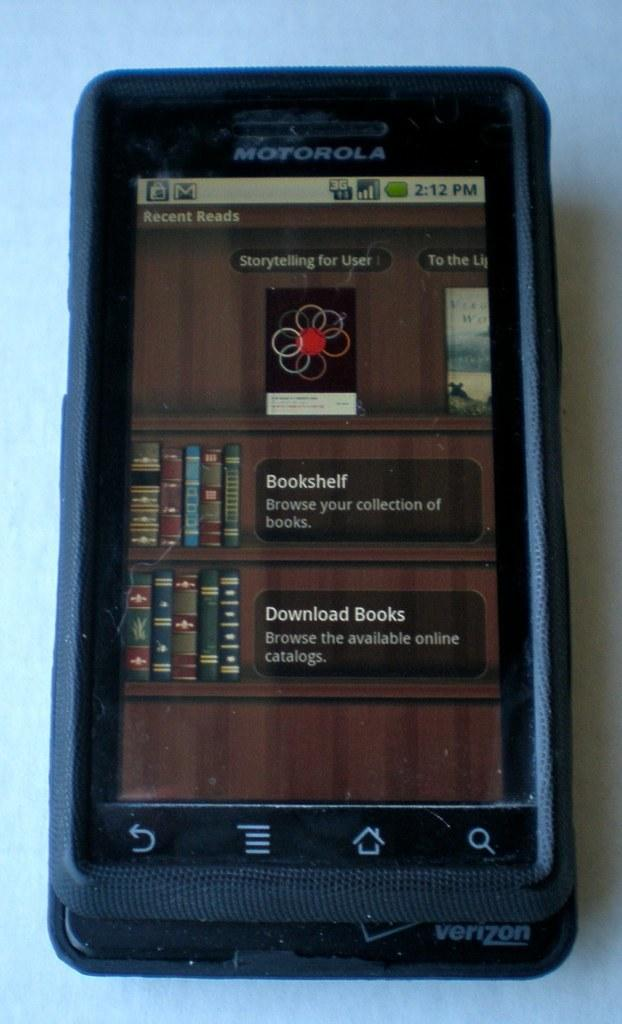Provide a one-sentence caption for the provided image. Motorola phone sits on a table displaying a bookshelf. 